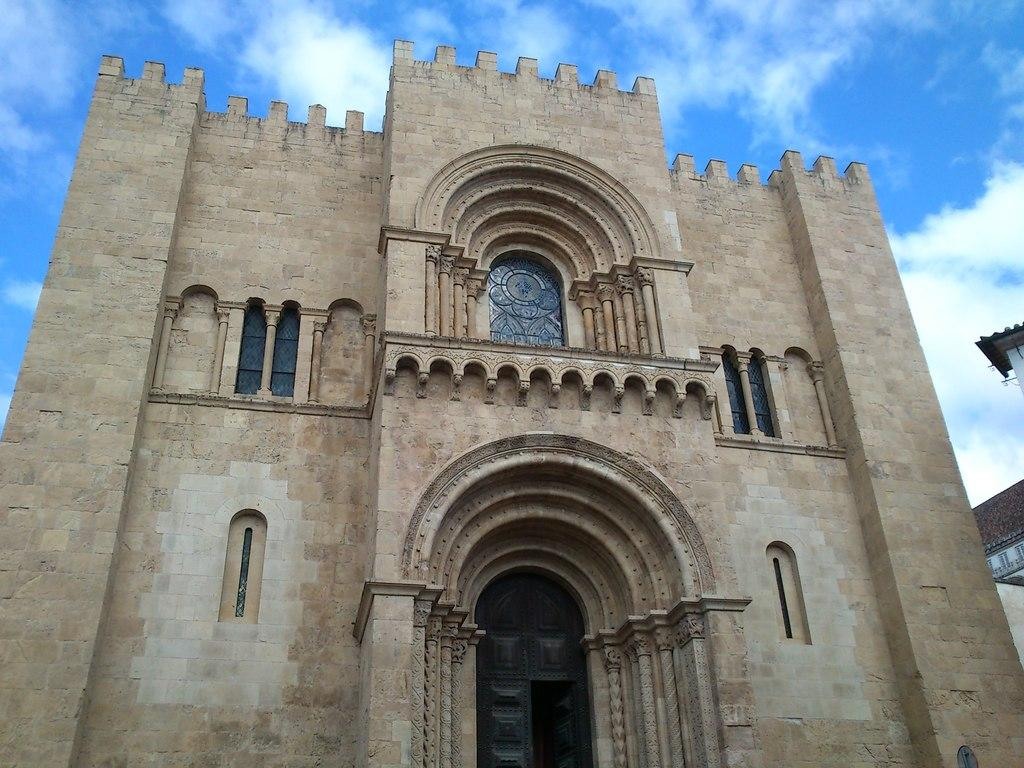What is the main subject in the center of the image? There is a building structure in the center of the image. What feature can be observed on the building structure? The building structure appears to have roofs. What can be seen in the background of the image? The sky is visible in the background of the image. Can you hear the sound of pleasure coming from the building structure in the image? There is no sound or indication of pleasure in the image; it is a visual representation of a building structure with roofs and a visible sky in the background. 